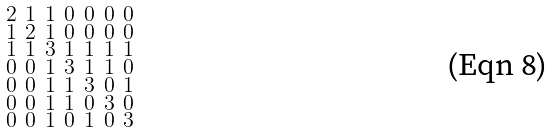Convert formula to latex. <formula><loc_0><loc_0><loc_500><loc_500>\begin{smallmatrix} 2 & 1 & 1 & 0 & 0 & 0 & 0 \\ 1 & 2 & 1 & 0 & 0 & 0 & 0 \\ 1 & 1 & 3 & 1 & 1 & 1 & 1 \\ 0 & 0 & 1 & 3 & 1 & 1 & 0 \\ 0 & 0 & 1 & 1 & 3 & 0 & 1 \\ 0 & 0 & 1 & 1 & 0 & 3 & 0 \\ 0 & 0 & 1 & 0 & 1 & 0 & 3 \end{smallmatrix}</formula> 